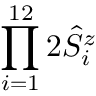Convert formula to latex. <formula><loc_0><loc_0><loc_500><loc_500>\prod _ { i = 1 } ^ { 1 2 } 2 \hat { S } _ { i } ^ { z }</formula> 